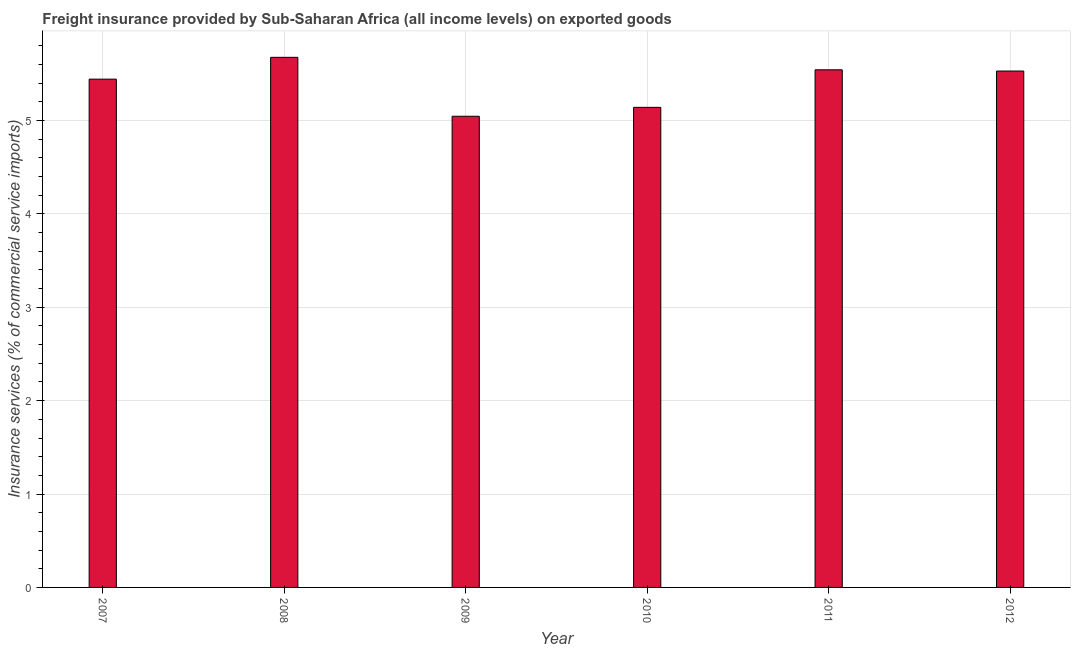What is the title of the graph?
Keep it short and to the point. Freight insurance provided by Sub-Saharan Africa (all income levels) on exported goods . What is the label or title of the X-axis?
Provide a short and direct response. Year. What is the label or title of the Y-axis?
Provide a short and direct response. Insurance services (% of commercial service imports). What is the freight insurance in 2011?
Ensure brevity in your answer.  5.54. Across all years, what is the maximum freight insurance?
Make the answer very short. 5.68. Across all years, what is the minimum freight insurance?
Offer a very short reply. 5.05. What is the sum of the freight insurance?
Provide a short and direct response. 32.38. What is the difference between the freight insurance in 2010 and 2011?
Provide a succinct answer. -0.4. What is the average freight insurance per year?
Your answer should be very brief. 5.4. What is the median freight insurance?
Ensure brevity in your answer.  5.49. What is the ratio of the freight insurance in 2007 to that in 2008?
Ensure brevity in your answer.  0.96. Is the freight insurance in 2010 less than that in 2012?
Provide a short and direct response. Yes. What is the difference between the highest and the second highest freight insurance?
Offer a very short reply. 0.13. Is the sum of the freight insurance in 2010 and 2012 greater than the maximum freight insurance across all years?
Give a very brief answer. Yes. What is the difference between the highest and the lowest freight insurance?
Offer a very short reply. 0.63. In how many years, is the freight insurance greater than the average freight insurance taken over all years?
Your response must be concise. 4. How many bars are there?
Offer a terse response. 6. What is the Insurance services (% of commercial service imports) of 2007?
Ensure brevity in your answer.  5.44. What is the Insurance services (% of commercial service imports) in 2008?
Make the answer very short. 5.68. What is the Insurance services (% of commercial service imports) in 2009?
Provide a succinct answer. 5.05. What is the Insurance services (% of commercial service imports) in 2010?
Offer a terse response. 5.14. What is the Insurance services (% of commercial service imports) in 2011?
Provide a succinct answer. 5.54. What is the Insurance services (% of commercial service imports) in 2012?
Provide a short and direct response. 5.53. What is the difference between the Insurance services (% of commercial service imports) in 2007 and 2008?
Your answer should be very brief. -0.23. What is the difference between the Insurance services (% of commercial service imports) in 2007 and 2009?
Make the answer very short. 0.4. What is the difference between the Insurance services (% of commercial service imports) in 2007 and 2010?
Provide a short and direct response. 0.3. What is the difference between the Insurance services (% of commercial service imports) in 2007 and 2011?
Offer a very short reply. -0.1. What is the difference between the Insurance services (% of commercial service imports) in 2007 and 2012?
Provide a short and direct response. -0.09. What is the difference between the Insurance services (% of commercial service imports) in 2008 and 2009?
Offer a terse response. 0.63. What is the difference between the Insurance services (% of commercial service imports) in 2008 and 2010?
Your response must be concise. 0.54. What is the difference between the Insurance services (% of commercial service imports) in 2008 and 2011?
Your answer should be very brief. 0.13. What is the difference between the Insurance services (% of commercial service imports) in 2008 and 2012?
Provide a short and direct response. 0.15. What is the difference between the Insurance services (% of commercial service imports) in 2009 and 2010?
Your answer should be compact. -0.1. What is the difference between the Insurance services (% of commercial service imports) in 2009 and 2011?
Give a very brief answer. -0.5. What is the difference between the Insurance services (% of commercial service imports) in 2009 and 2012?
Provide a short and direct response. -0.48. What is the difference between the Insurance services (% of commercial service imports) in 2010 and 2011?
Ensure brevity in your answer.  -0.4. What is the difference between the Insurance services (% of commercial service imports) in 2010 and 2012?
Make the answer very short. -0.39. What is the difference between the Insurance services (% of commercial service imports) in 2011 and 2012?
Make the answer very short. 0.01. What is the ratio of the Insurance services (% of commercial service imports) in 2007 to that in 2009?
Give a very brief answer. 1.08. What is the ratio of the Insurance services (% of commercial service imports) in 2007 to that in 2010?
Offer a terse response. 1.06. What is the ratio of the Insurance services (% of commercial service imports) in 2007 to that in 2012?
Your answer should be compact. 0.98. What is the ratio of the Insurance services (% of commercial service imports) in 2008 to that in 2009?
Give a very brief answer. 1.12. What is the ratio of the Insurance services (% of commercial service imports) in 2008 to that in 2010?
Give a very brief answer. 1.1. What is the ratio of the Insurance services (% of commercial service imports) in 2008 to that in 2012?
Offer a very short reply. 1.03. What is the ratio of the Insurance services (% of commercial service imports) in 2009 to that in 2010?
Your answer should be very brief. 0.98. What is the ratio of the Insurance services (% of commercial service imports) in 2009 to that in 2011?
Your answer should be very brief. 0.91. What is the ratio of the Insurance services (% of commercial service imports) in 2009 to that in 2012?
Give a very brief answer. 0.91. What is the ratio of the Insurance services (% of commercial service imports) in 2010 to that in 2011?
Provide a short and direct response. 0.93. 